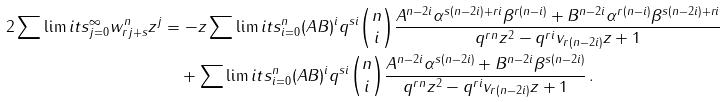<formula> <loc_0><loc_0><loc_500><loc_500>2 \sum \lim i t s _ { j = 0 } ^ { \infty } { w _ { r j + s } ^ { n } z ^ { j } } & = - z \sum \lim i t s _ { i = 0 } ^ { n } { ( A B ) ^ { i } q ^ { s i } \binom { n } { i } \frac { { A ^ { n - 2 i } \alpha ^ { s ( n - 2 i ) + r i } \beta ^ { r ( n - i ) } + B ^ { n - 2 i } \alpha ^ { r ( n - i ) } \beta ^ { s ( n - 2 i ) + r i } } } { { q ^ { r n } z ^ { 2 } - q ^ { r i } v _ { r ( n - 2 i ) } z + 1 } } } \\ & \quad + \sum \lim i t s _ { i = 0 } ^ { n } { ( A B ) ^ { i } q ^ { s i } \binom { n } { i } \frac { { A ^ { n - 2 i } \alpha ^ { s ( n - 2 i ) } + B ^ { n - 2 i } \beta ^ { s ( n - 2 i ) } } } { { q ^ { r n } z ^ { 2 } - q ^ { r i } v _ { r ( n - 2 i ) } z + 1 } } } \, .</formula> 